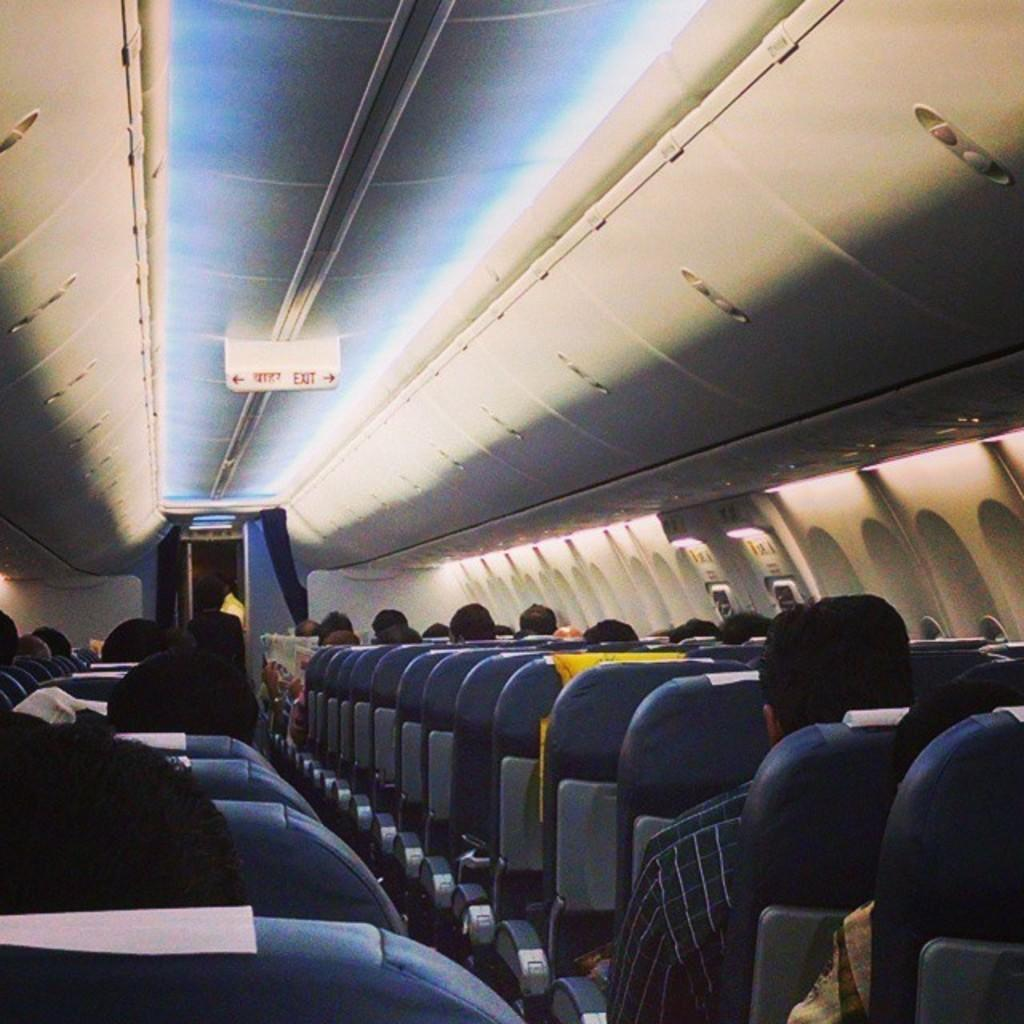<image>
Summarize the visual content of the image. the word exit is on the roof of the plane 